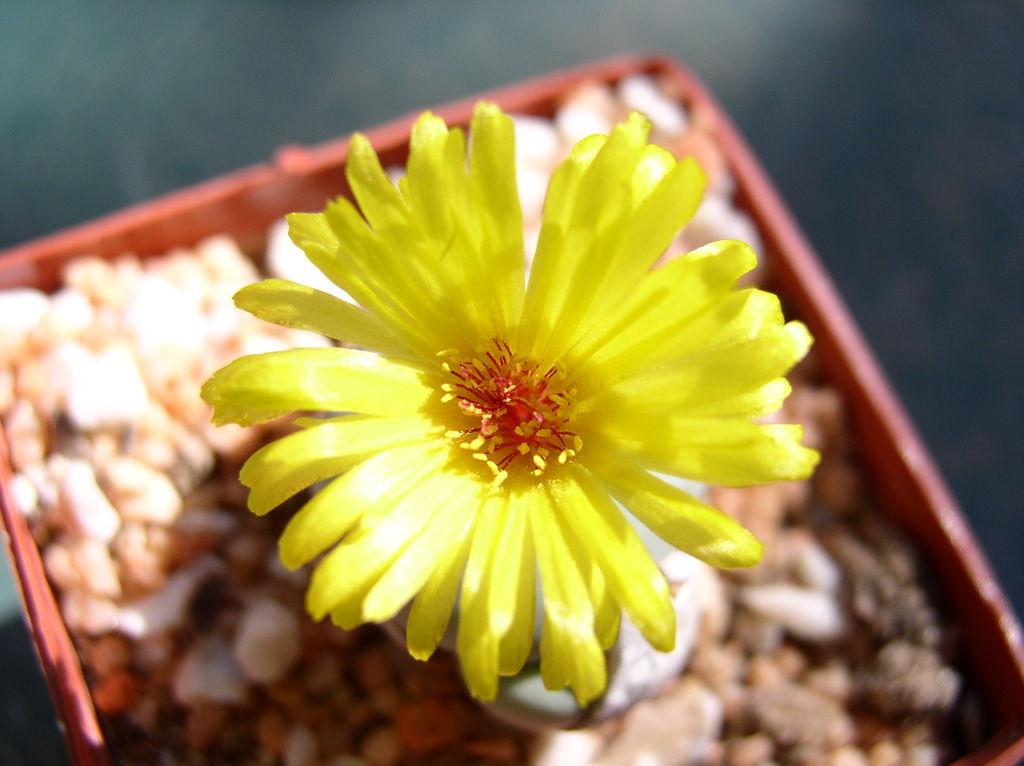What is the main object in the image? There is a flower in the image. How is the flower being displayed or contained? The flower is in a basket. What other items are present in the basket with the flower? There are stones and rocks in the basket. What month does the owner of the flower prefer? There is no information about the owner of the flower in the image, so we cannot determine their preferred month. 